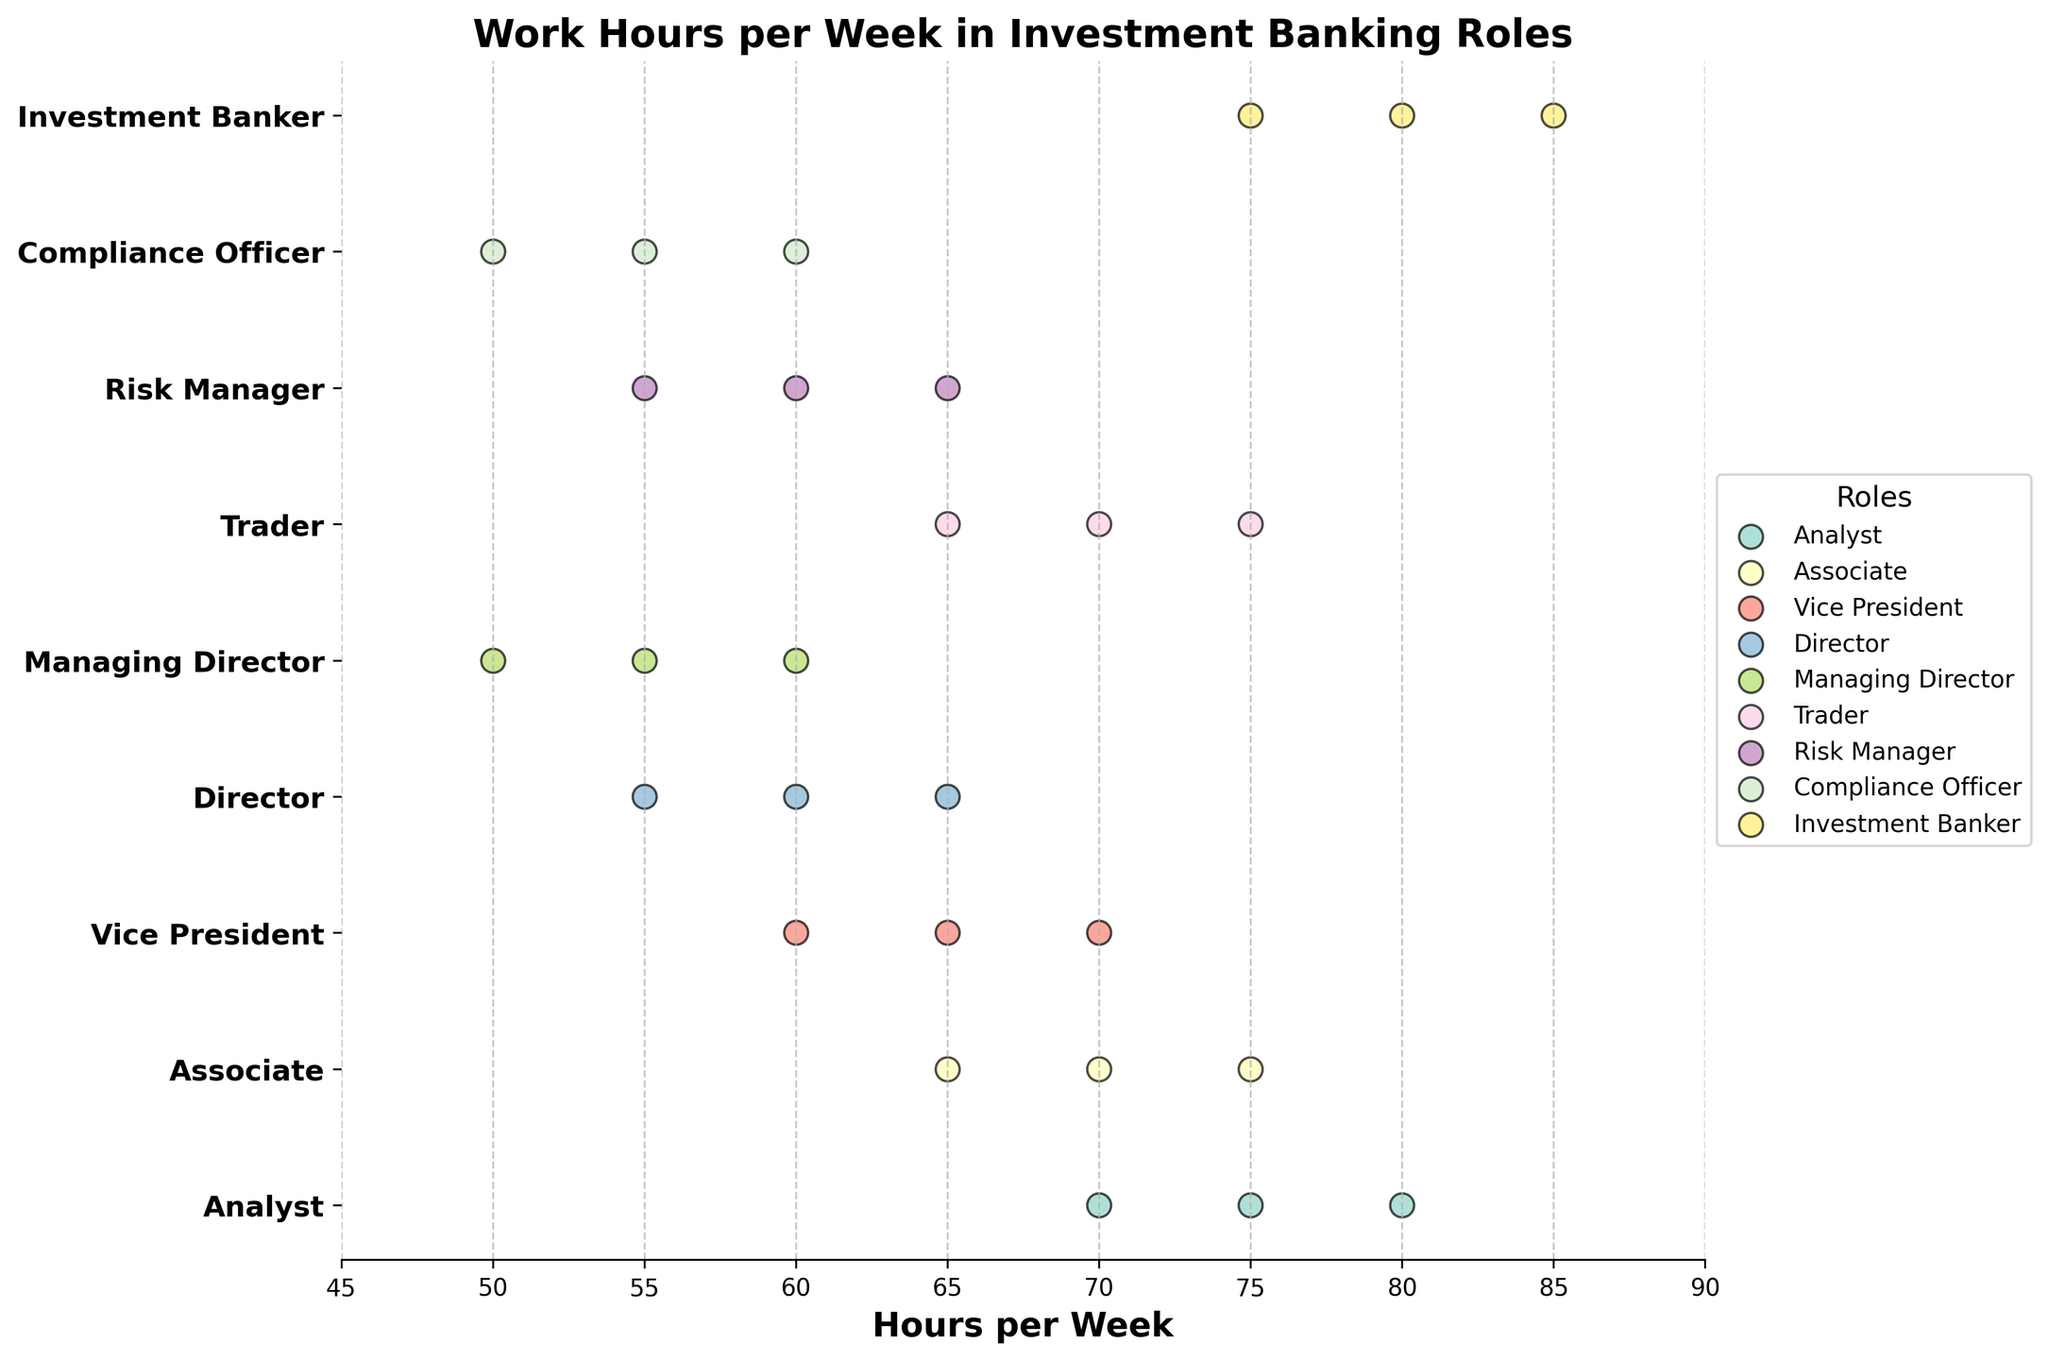What is the title of the plot? The title of the plot is usually found at the top-center of the figure and is often bolded for emphasis.
Answer: Work Hours per Week in Investment Banking Roles Which role works the most hours on average? We look at the spread and central tendency of the dots for each role. The roles with dots generally positioned further to the right (higher on the x-axis) are working more hours on average. The Investment Banker role has the highest range of hours from 75 to 85 per week.
Answer: Investment Banker What is the range of hours worked by Analysts? The range is determined by the minimum and maximum values for the Analyst dots. Identifying the extreme points on the horizontal axis for this role reveals the range.
Answer: 70 to 80 How do the work hours of Vice Presidents compare with those of Directors? Compare the clusters of dots for Vice Presidents and Directors along the horizontal axis to see which role has dots positioned further right (more hours) or left (fewer hours). Vice Presidents work between 60-70 hours, whereas Directors work between 55-65 hours.
Answer: Vice Presidents generally work more hours than Directors How many different roles are depicted in the plot? The number of unique tick labels on the y-axis represents the number of different roles in the figure. Counting these labels gives the answer.
Answer: 8 What is the most common work hour value for Managing Directors? Locate the cluster of dots for Managing Directors and see which value is most frequently repeated. Looking at the dots for Managing Directors, 55 hours is repeated twice.
Answer: 55 hours Between a Trader and a Compliance Officer, which role has the broader range of work hours? Determine the range (maximum - minimum) of hours for both Traders and Compliance Officers. A wider horizontal spread of dots indicates a broader range. Traders have a range of 65-75 hours, while Compliance Officers have a range of 50-60 hours.
Answer: Trader How do work hours for Analysts compare to Investment Bankers? Comparing the horizontal spread and central positioning of dots for Analysts and Investment Bankers reveals that Investment Bankers have both higher minimum and maximum hours. Analysts work 70-80 hours, whereas Investment Bankers work 75-85 hours.
Answer: Investment Bankers generally work more hours than Analysts What is the average number of work hours for Associates? Identify the dots for Associates, sum up their hours, and divide by the number of data points (which are 3 in this case). Sum: 65 + 70 + 75 = 210. Average: 210 / 3 = 70
Answer: 70 Which role works the least hours per week on average? Look at the spread and position of the dots for each role. The role with the furthest left positioning dots indicates fewer hours. Compliance Officer dots are positioned at 50, 55, and 60 hours, indicating the least hours worked.
Answer: Compliance Officer 